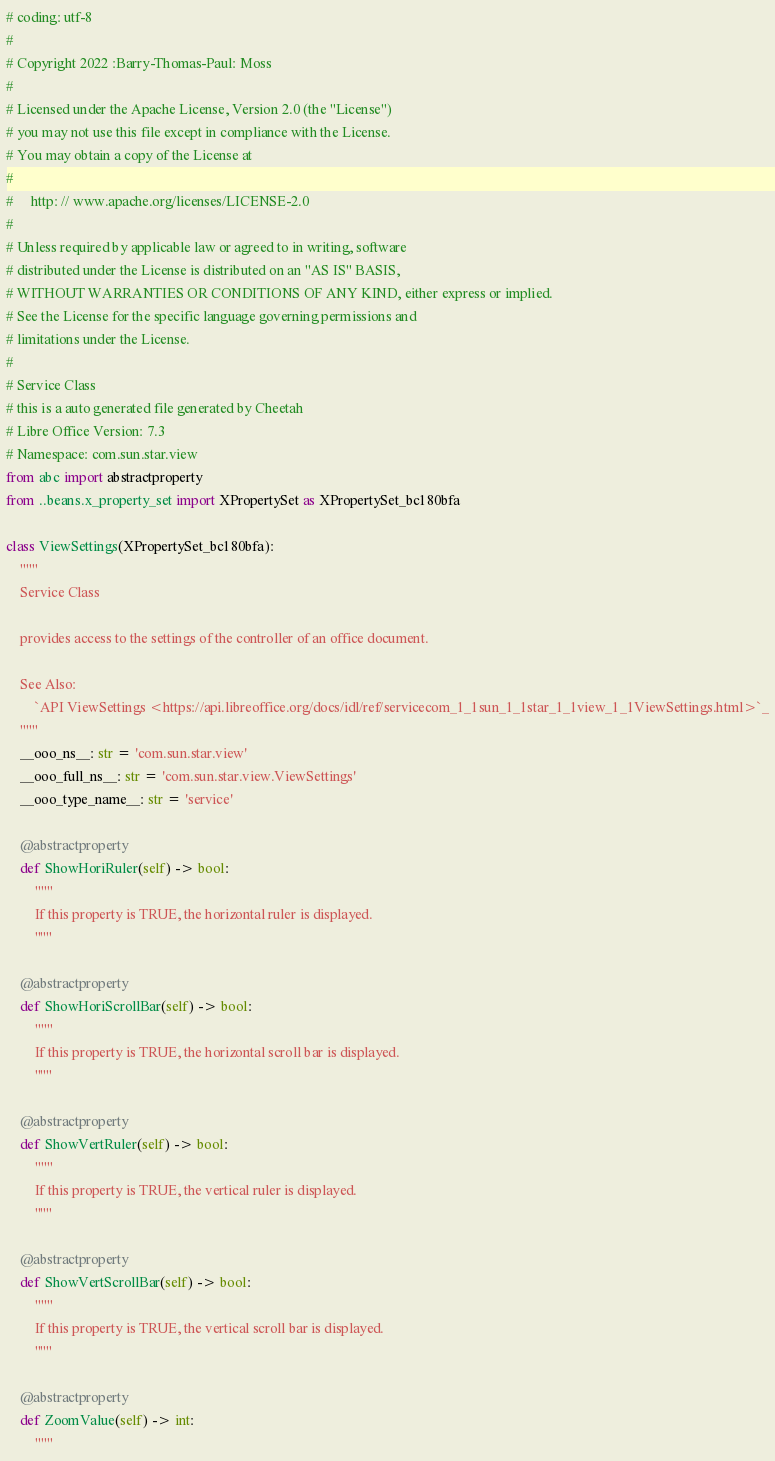Convert code to text. <code><loc_0><loc_0><loc_500><loc_500><_Python_># coding: utf-8
#
# Copyright 2022 :Barry-Thomas-Paul: Moss
#
# Licensed under the Apache License, Version 2.0 (the "License")
# you may not use this file except in compliance with the License.
# You may obtain a copy of the License at
#
#     http: // www.apache.org/licenses/LICENSE-2.0
#
# Unless required by applicable law or agreed to in writing, software
# distributed under the License is distributed on an "AS IS" BASIS,
# WITHOUT WARRANTIES OR CONDITIONS OF ANY KIND, either express or implied.
# See the License for the specific language governing permissions and
# limitations under the License.
#
# Service Class
# this is a auto generated file generated by Cheetah
# Libre Office Version: 7.3
# Namespace: com.sun.star.view
from abc import abstractproperty
from ..beans.x_property_set import XPropertySet as XPropertySet_bc180bfa

class ViewSettings(XPropertySet_bc180bfa):
    """
    Service Class

    provides access to the settings of the controller of an office document.

    See Also:
        `API ViewSettings <https://api.libreoffice.org/docs/idl/ref/servicecom_1_1sun_1_1star_1_1view_1_1ViewSettings.html>`_
    """
    __ooo_ns__: str = 'com.sun.star.view'
    __ooo_full_ns__: str = 'com.sun.star.view.ViewSettings'
    __ooo_type_name__: str = 'service'

    @abstractproperty
    def ShowHoriRuler(self) -> bool:
        """
        If this property is TRUE, the horizontal ruler is displayed.
        """

    @abstractproperty
    def ShowHoriScrollBar(self) -> bool:
        """
        If this property is TRUE, the horizontal scroll bar is displayed.
        """

    @abstractproperty
    def ShowVertRuler(self) -> bool:
        """
        If this property is TRUE, the vertical ruler is displayed.
        """

    @abstractproperty
    def ShowVertScrollBar(self) -> bool:
        """
        If this property is TRUE, the vertical scroll bar is displayed.
        """

    @abstractproperty
    def ZoomValue(self) -> int:
        """</code> 